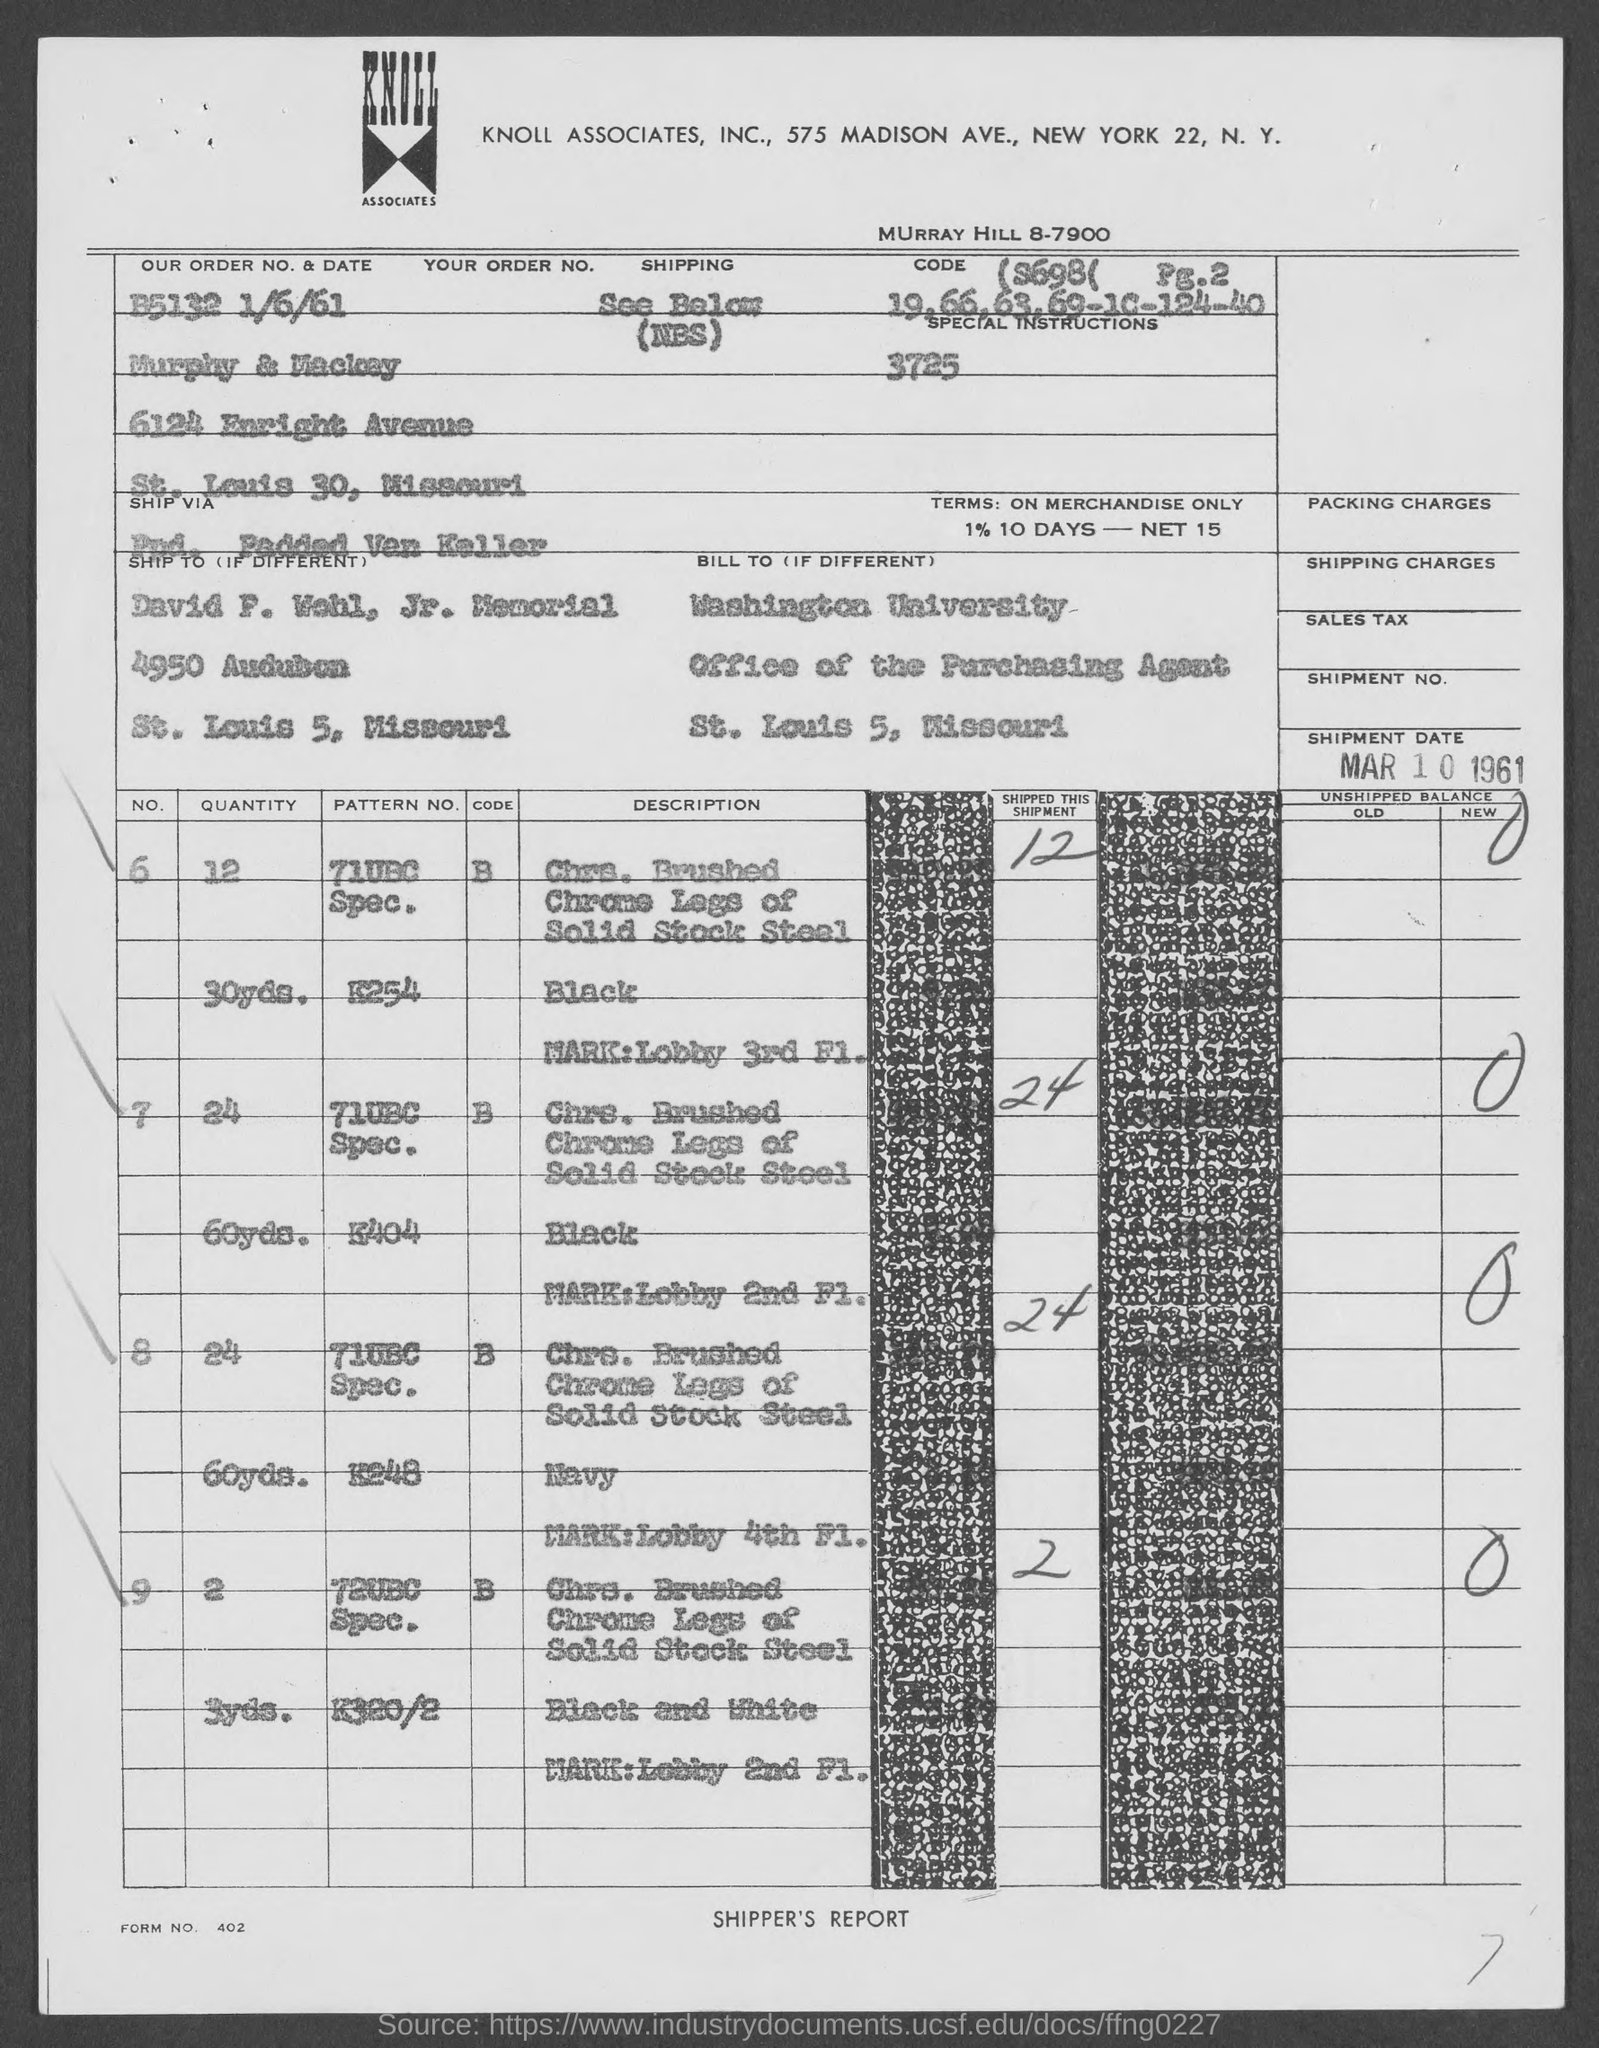Outline some significant characteristics in this image. The order number is B5132 and the date is 1/6/61, as mentioned in the document. The shipment date provided in the document is March 10, 1961. Washington University is mentioned in the billing address. The Knoll Associates is mentioned in the header of the document. 